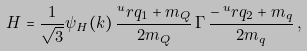<formula> <loc_0><loc_0><loc_500><loc_500>H = \frac { 1 } { \sqrt { 3 } } \psi _ { H } ( k ) \, \frac { ^ { u } r { q _ { 1 } } + m _ { Q } } { 2 m _ { Q } } \, \Gamma \, \frac { - \, ^ { u } r { q _ { 2 } } + m _ { q } } { 2 m _ { q } } \, ,</formula> 